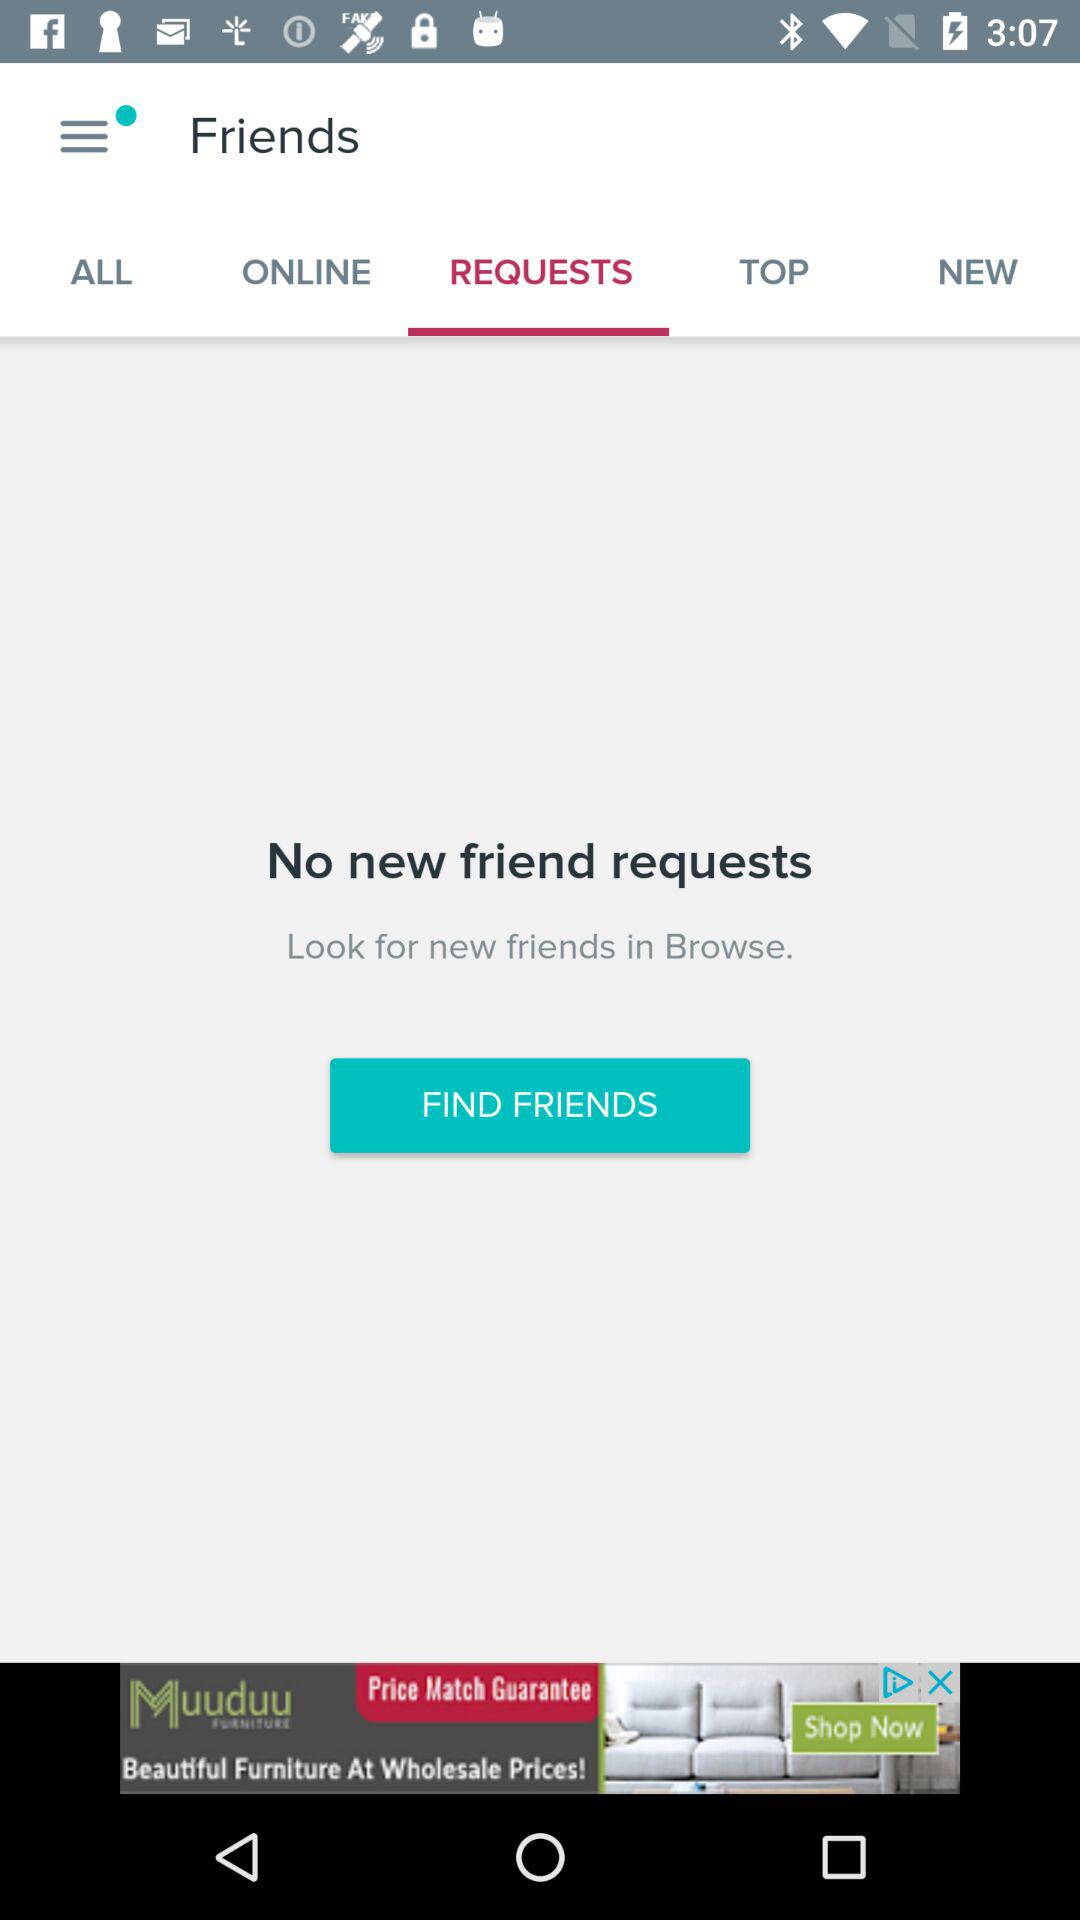Which tab is selected? The selected tab is "REQUESTS". 